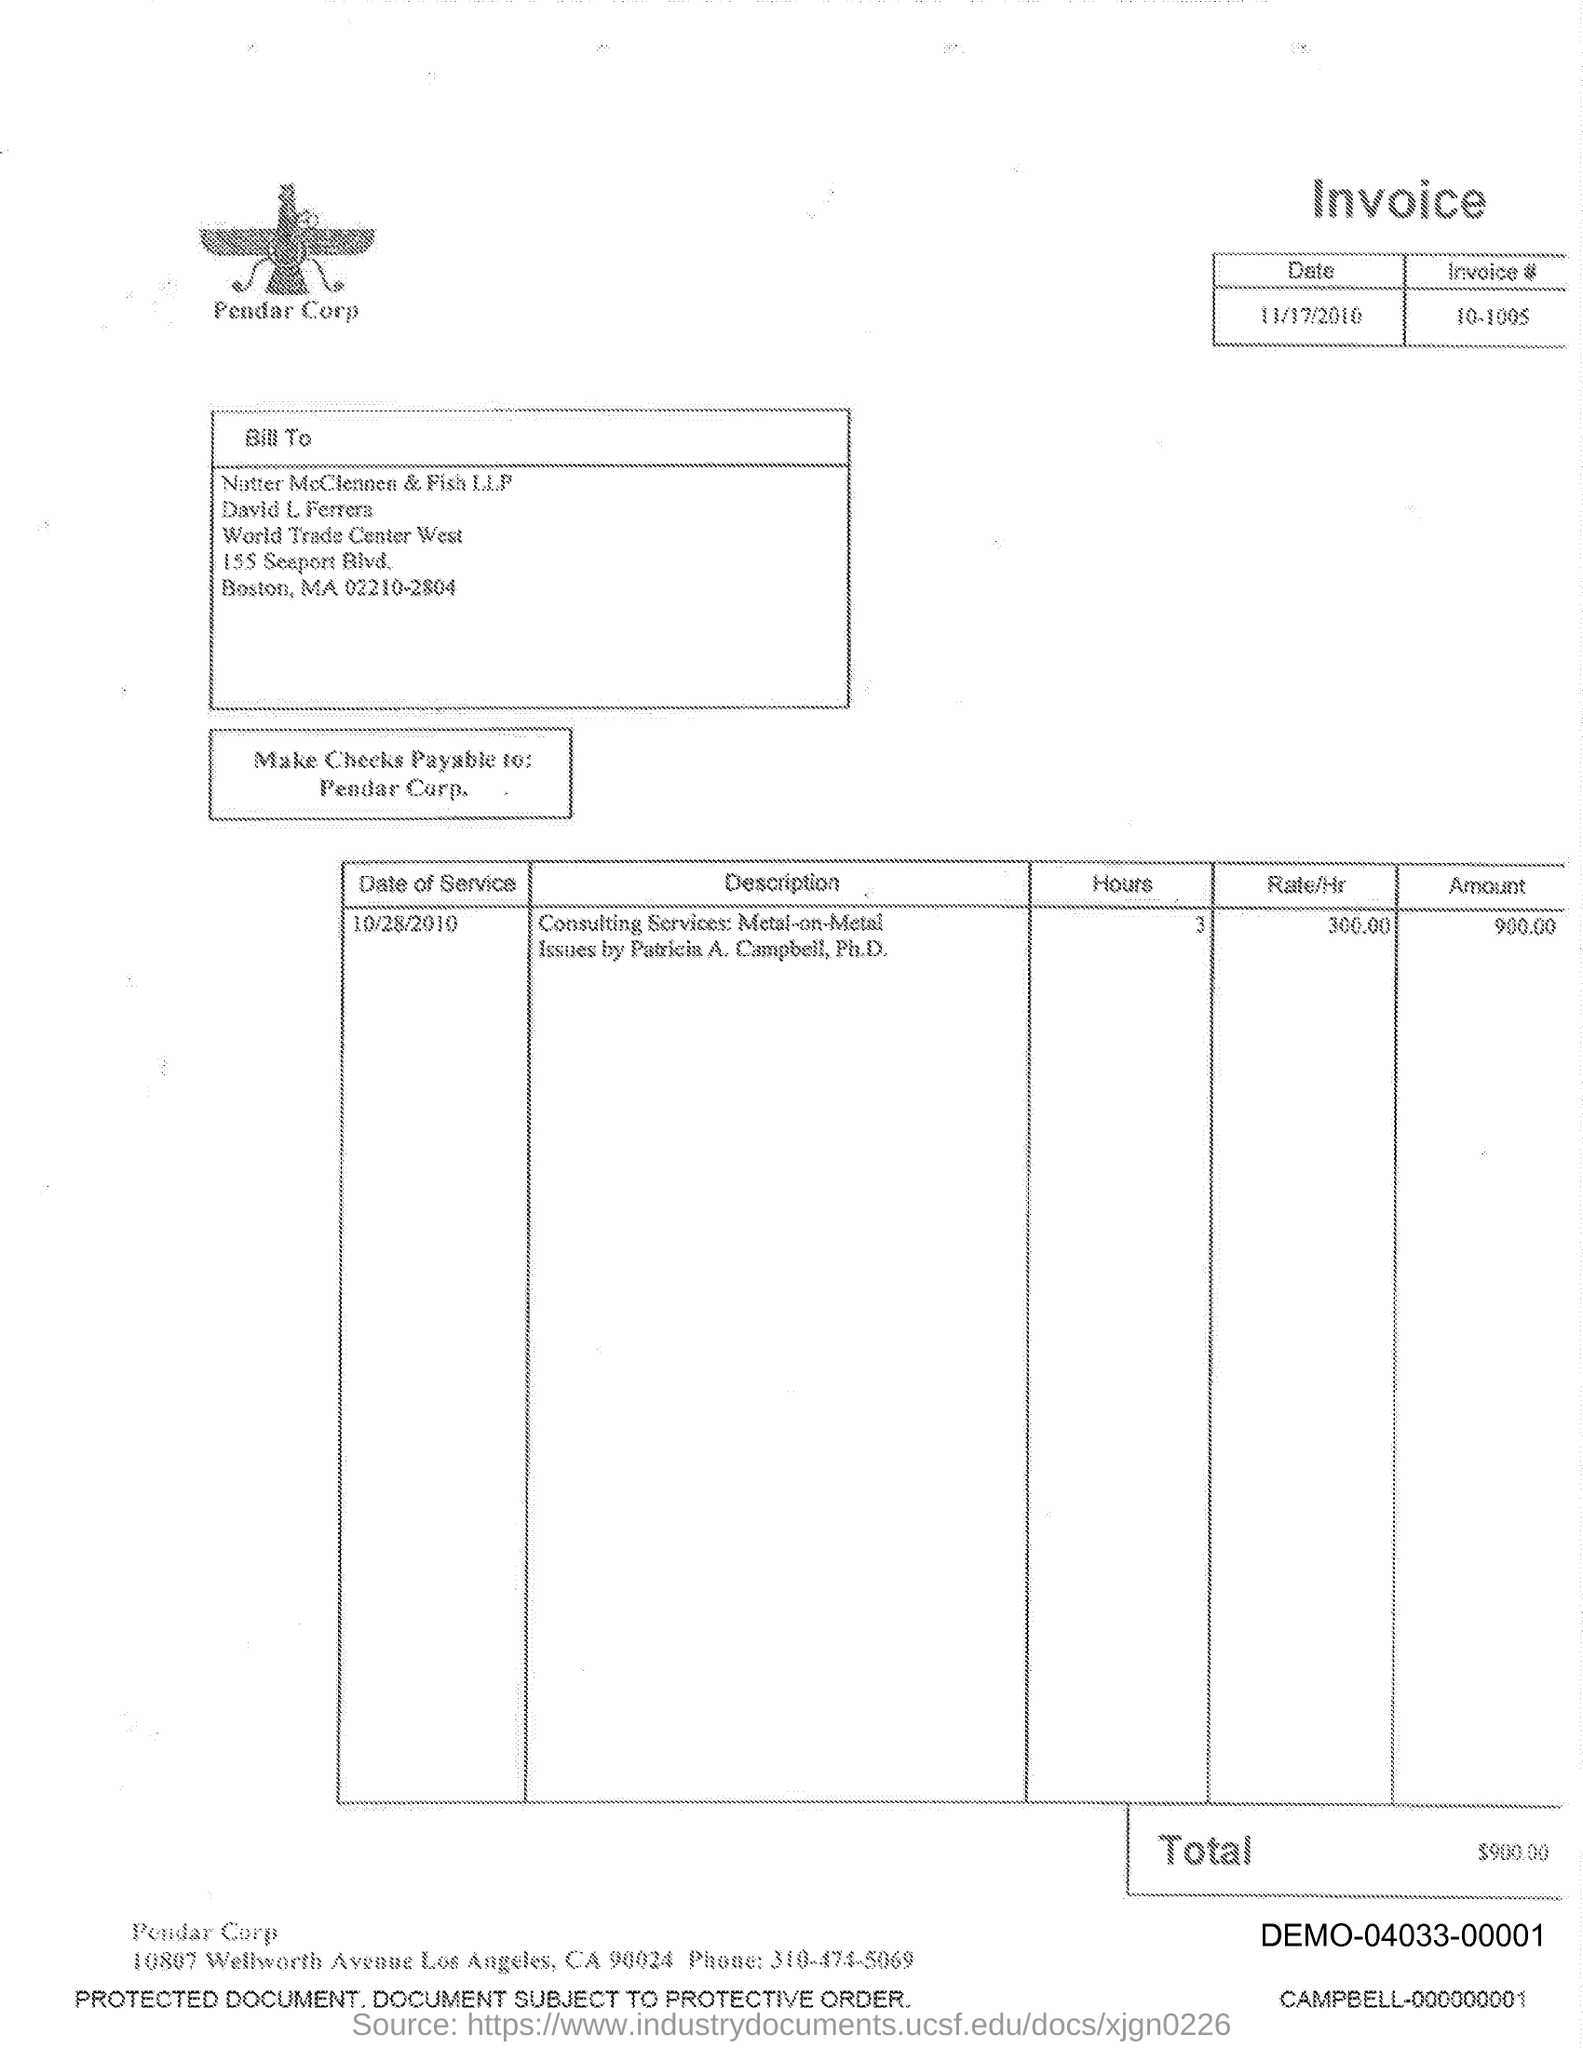Mention a couple of crucial points in this snapshot. The text written below the image is 'Pendar Corp.' 